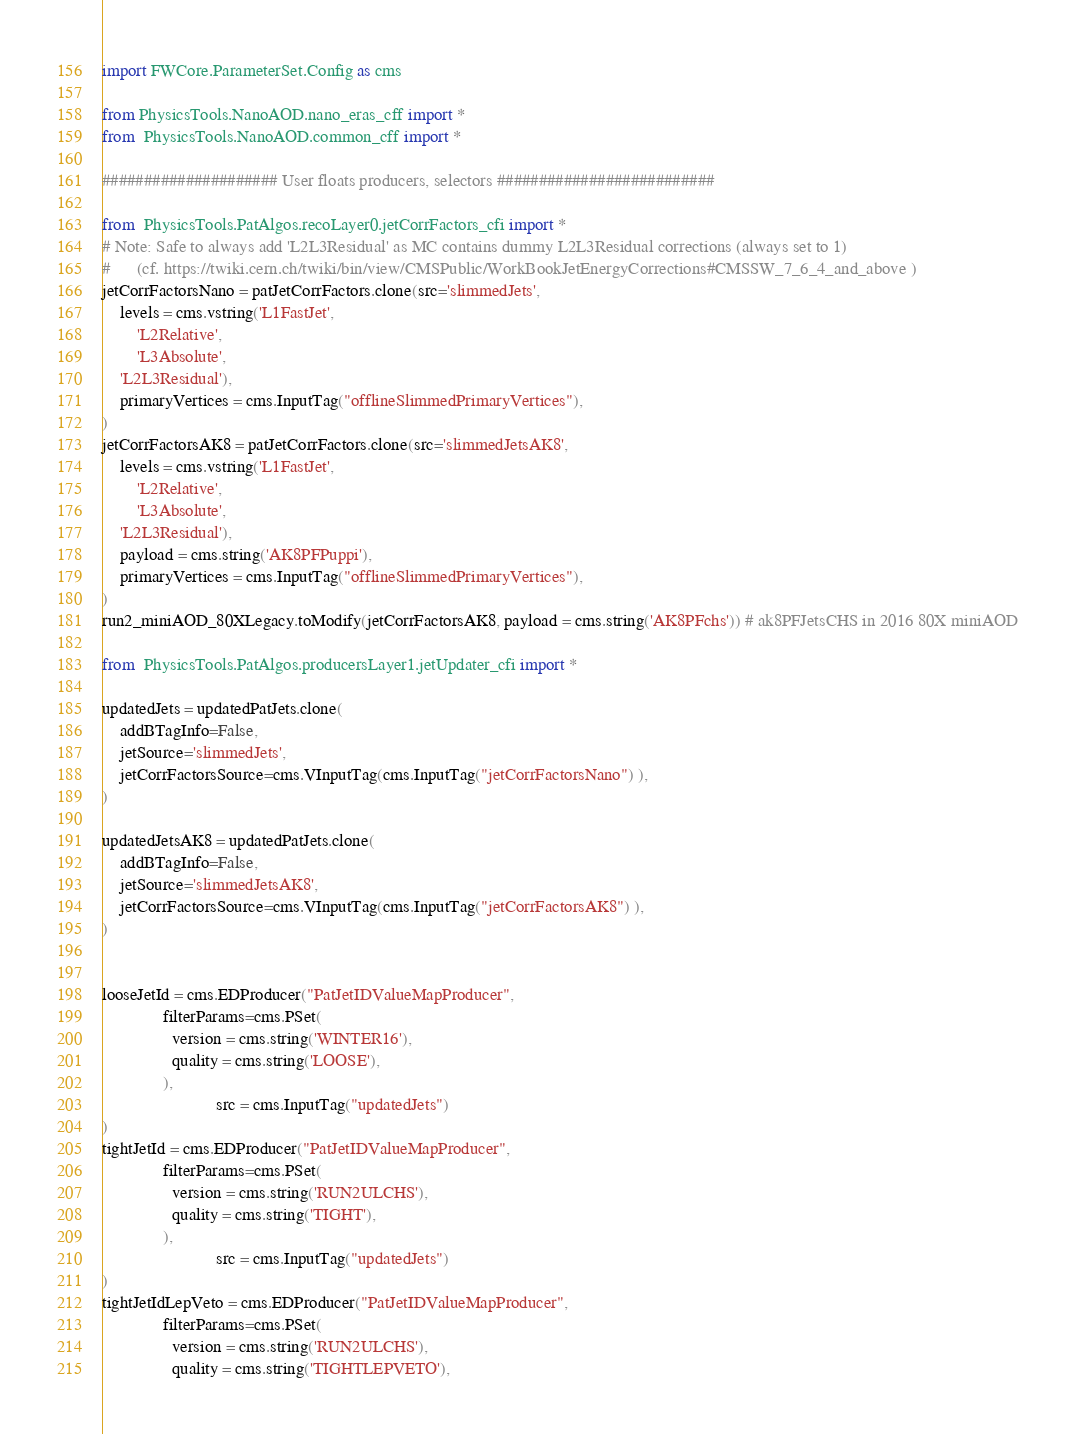<code> <loc_0><loc_0><loc_500><loc_500><_Python_>import FWCore.ParameterSet.Config as cms

from PhysicsTools.NanoAOD.nano_eras_cff import *
from  PhysicsTools.NanoAOD.common_cff import *

##################### User floats producers, selectors ##########################

from  PhysicsTools.PatAlgos.recoLayer0.jetCorrFactors_cfi import *
# Note: Safe to always add 'L2L3Residual' as MC contains dummy L2L3Residual corrections (always set to 1)
#      (cf. https://twiki.cern.ch/twiki/bin/view/CMSPublic/WorkBookJetEnergyCorrections#CMSSW_7_6_4_and_above )
jetCorrFactorsNano = patJetCorrFactors.clone(src='slimmedJets',
    levels = cms.vstring('L1FastJet',
        'L2Relative',
        'L3Absolute',
	'L2L3Residual'),
    primaryVertices = cms.InputTag("offlineSlimmedPrimaryVertices"),
)
jetCorrFactorsAK8 = patJetCorrFactors.clone(src='slimmedJetsAK8',
    levels = cms.vstring('L1FastJet',
        'L2Relative',
        'L3Absolute',
	'L2L3Residual'),
    payload = cms.string('AK8PFPuppi'),
    primaryVertices = cms.InputTag("offlineSlimmedPrimaryVertices"),
)
run2_miniAOD_80XLegacy.toModify(jetCorrFactorsAK8, payload = cms.string('AK8PFchs')) # ak8PFJetsCHS in 2016 80X miniAOD

from  PhysicsTools.PatAlgos.producersLayer1.jetUpdater_cfi import *

updatedJets = updatedPatJets.clone(
	addBTagInfo=False,
	jetSource='slimmedJets',
	jetCorrFactorsSource=cms.VInputTag(cms.InputTag("jetCorrFactorsNano") ),
)

updatedJetsAK8 = updatedPatJets.clone(
	addBTagInfo=False,
	jetSource='slimmedJetsAK8',
	jetCorrFactorsSource=cms.VInputTag(cms.InputTag("jetCorrFactorsAK8") ),
)


looseJetId = cms.EDProducer("PatJetIDValueMapProducer",
			  filterParams=cms.PSet(
			    version = cms.string('WINTER16'),
			    quality = cms.string('LOOSE'),
			  ),
                          src = cms.InputTag("updatedJets")
)
tightJetId = cms.EDProducer("PatJetIDValueMapProducer",
			  filterParams=cms.PSet(
			    version = cms.string('RUN2ULCHS'),
			    quality = cms.string('TIGHT'),
			  ),
                          src = cms.InputTag("updatedJets")
)
tightJetIdLepVeto = cms.EDProducer("PatJetIDValueMapProducer",
			  filterParams=cms.PSet(
			    version = cms.string('RUN2ULCHS'),
			    quality = cms.string('TIGHTLEPVETO'),</code> 